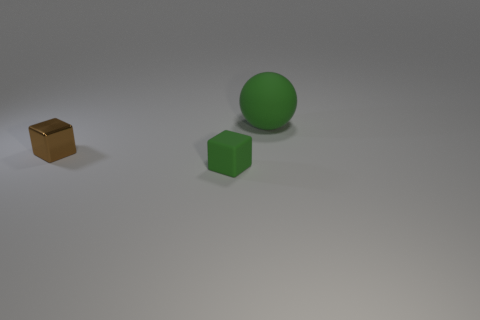Add 3 green cubes. How many objects exist? 6 Subtract all spheres. How many objects are left? 2 Subtract 0 gray cylinders. How many objects are left? 3 Subtract all small things. Subtract all green rubber blocks. How many objects are left? 0 Add 3 small rubber blocks. How many small rubber blocks are left? 4 Add 3 small green rubber blocks. How many small green rubber blocks exist? 4 